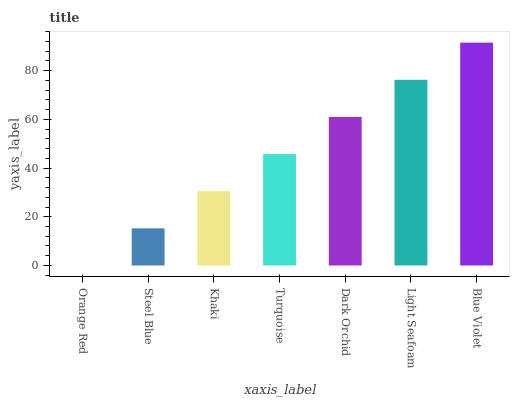Is Orange Red the minimum?
Answer yes or no. Yes. Is Blue Violet the maximum?
Answer yes or no. Yes. Is Steel Blue the minimum?
Answer yes or no. No. Is Steel Blue the maximum?
Answer yes or no. No. Is Steel Blue greater than Orange Red?
Answer yes or no. Yes. Is Orange Red less than Steel Blue?
Answer yes or no. Yes. Is Orange Red greater than Steel Blue?
Answer yes or no. No. Is Steel Blue less than Orange Red?
Answer yes or no. No. Is Turquoise the high median?
Answer yes or no. Yes. Is Turquoise the low median?
Answer yes or no. Yes. Is Dark Orchid the high median?
Answer yes or no. No. Is Khaki the low median?
Answer yes or no. No. 